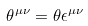Convert formula to latex. <formula><loc_0><loc_0><loc_500><loc_500>\theta ^ { \mu \nu } = \theta \epsilon ^ { \mu \nu }</formula> 